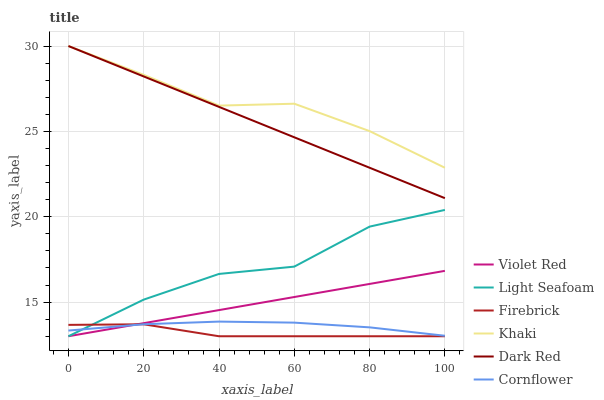Does Firebrick have the minimum area under the curve?
Answer yes or no. Yes. Does Khaki have the maximum area under the curve?
Answer yes or no. Yes. Does Violet Red have the minimum area under the curve?
Answer yes or no. No. Does Violet Red have the maximum area under the curve?
Answer yes or no. No. Is Violet Red the smoothest?
Answer yes or no. Yes. Is Light Seafoam the roughest?
Answer yes or no. Yes. Is Khaki the smoothest?
Answer yes or no. No. Is Khaki the roughest?
Answer yes or no. No. Does Violet Red have the lowest value?
Answer yes or no. Yes. Does Khaki have the lowest value?
Answer yes or no. No. Does Dark Red have the highest value?
Answer yes or no. Yes. Does Violet Red have the highest value?
Answer yes or no. No. Is Firebrick less than Dark Red?
Answer yes or no. Yes. Is Dark Red greater than Light Seafoam?
Answer yes or no. Yes. Does Light Seafoam intersect Cornflower?
Answer yes or no. Yes. Is Light Seafoam less than Cornflower?
Answer yes or no. No. Is Light Seafoam greater than Cornflower?
Answer yes or no. No. Does Firebrick intersect Dark Red?
Answer yes or no. No. 